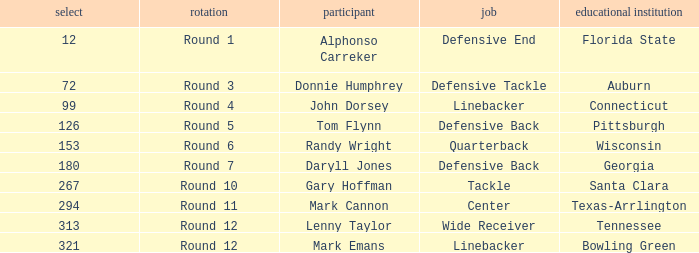In what Round was Pick #12 drafted? Round 1. 